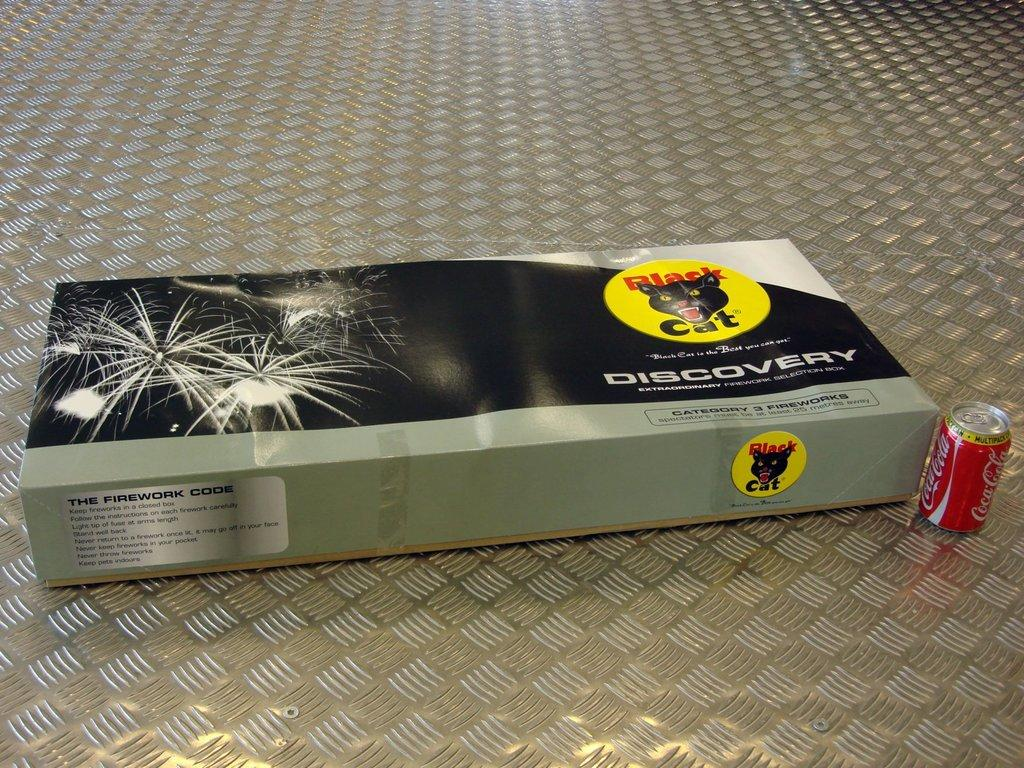<image>
Render a clear and concise summary of the photo. a box of Black Cat Discovery with fireworks inside 